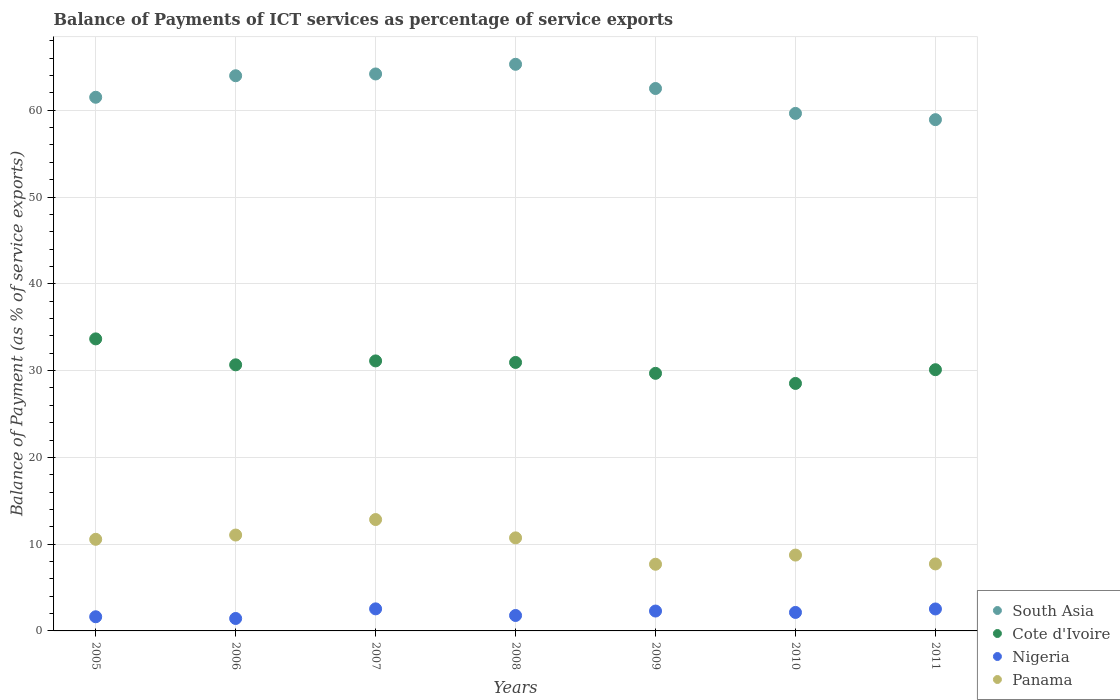How many different coloured dotlines are there?
Your response must be concise. 4. Is the number of dotlines equal to the number of legend labels?
Your response must be concise. Yes. What is the balance of payments of ICT services in Panama in 2009?
Keep it short and to the point. 7.68. Across all years, what is the maximum balance of payments of ICT services in Panama?
Provide a short and direct response. 12.83. Across all years, what is the minimum balance of payments of ICT services in South Asia?
Offer a terse response. 58.92. What is the total balance of payments of ICT services in Cote d'Ivoire in the graph?
Offer a terse response. 214.68. What is the difference between the balance of payments of ICT services in Panama in 2006 and that in 2008?
Ensure brevity in your answer.  0.33. What is the difference between the balance of payments of ICT services in Cote d'Ivoire in 2006 and the balance of payments of ICT services in Nigeria in 2005?
Offer a terse response. 29.03. What is the average balance of payments of ICT services in Nigeria per year?
Make the answer very short. 2.05. In the year 2011, what is the difference between the balance of payments of ICT services in Panama and balance of payments of ICT services in South Asia?
Your answer should be very brief. -51.2. In how many years, is the balance of payments of ICT services in Cote d'Ivoire greater than 30 %?
Offer a terse response. 5. What is the ratio of the balance of payments of ICT services in Cote d'Ivoire in 2006 to that in 2009?
Offer a terse response. 1.03. Is the balance of payments of ICT services in Panama in 2007 less than that in 2009?
Give a very brief answer. No. What is the difference between the highest and the second highest balance of payments of ICT services in Cote d'Ivoire?
Make the answer very short. 2.54. What is the difference between the highest and the lowest balance of payments of ICT services in Cote d'Ivoire?
Your response must be concise. 5.13. In how many years, is the balance of payments of ICT services in Panama greater than the average balance of payments of ICT services in Panama taken over all years?
Your answer should be very brief. 4. Is it the case that in every year, the sum of the balance of payments of ICT services in South Asia and balance of payments of ICT services in Panama  is greater than the sum of balance of payments of ICT services in Cote d'Ivoire and balance of payments of ICT services in Nigeria?
Give a very brief answer. No. Is it the case that in every year, the sum of the balance of payments of ICT services in South Asia and balance of payments of ICT services in Cote d'Ivoire  is greater than the balance of payments of ICT services in Panama?
Your response must be concise. Yes. Does the balance of payments of ICT services in South Asia monotonically increase over the years?
Offer a terse response. No. Is the balance of payments of ICT services in Panama strictly greater than the balance of payments of ICT services in South Asia over the years?
Give a very brief answer. No. How many dotlines are there?
Offer a very short reply. 4. How many years are there in the graph?
Your answer should be compact. 7. What is the difference between two consecutive major ticks on the Y-axis?
Offer a terse response. 10. How many legend labels are there?
Your answer should be very brief. 4. What is the title of the graph?
Offer a terse response. Balance of Payments of ICT services as percentage of service exports. What is the label or title of the Y-axis?
Your answer should be compact. Balance of Payment (as % of service exports). What is the Balance of Payment (as % of service exports) in South Asia in 2005?
Provide a succinct answer. 61.5. What is the Balance of Payment (as % of service exports) of Cote d'Ivoire in 2005?
Keep it short and to the point. 33.65. What is the Balance of Payment (as % of service exports) in Nigeria in 2005?
Offer a terse response. 1.63. What is the Balance of Payment (as % of service exports) of Panama in 2005?
Offer a very short reply. 10.56. What is the Balance of Payment (as % of service exports) in South Asia in 2006?
Offer a very short reply. 63.98. What is the Balance of Payment (as % of service exports) of Cote d'Ivoire in 2006?
Keep it short and to the point. 30.67. What is the Balance of Payment (as % of service exports) in Nigeria in 2006?
Make the answer very short. 1.43. What is the Balance of Payment (as % of service exports) of Panama in 2006?
Offer a terse response. 11.05. What is the Balance of Payment (as % of service exports) in South Asia in 2007?
Offer a terse response. 64.18. What is the Balance of Payment (as % of service exports) of Cote d'Ivoire in 2007?
Your response must be concise. 31.12. What is the Balance of Payment (as % of service exports) of Nigeria in 2007?
Offer a terse response. 2.54. What is the Balance of Payment (as % of service exports) of Panama in 2007?
Make the answer very short. 12.83. What is the Balance of Payment (as % of service exports) of South Asia in 2008?
Give a very brief answer. 65.3. What is the Balance of Payment (as % of service exports) in Cote d'Ivoire in 2008?
Offer a terse response. 30.94. What is the Balance of Payment (as % of service exports) in Nigeria in 2008?
Make the answer very short. 1.78. What is the Balance of Payment (as % of service exports) of Panama in 2008?
Your response must be concise. 10.72. What is the Balance of Payment (as % of service exports) in South Asia in 2009?
Offer a very short reply. 62.51. What is the Balance of Payment (as % of service exports) in Cote d'Ivoire in 2009?
Provide a short and direct response. 29.68. What is the Balance of Payment (as % of service exports) in Nigeria in 2009?
Your answer should be compact. 2.29. What is the Balance of Payment (as % of service exports) of Panama in 2009?
Your answer should be compact. 7.68. What is the Balance of Payment (as % of service exports) of South Asia in 2010?
Your answer should be very brief. 59.64. What is the Balance of Payment (as % of service exports) of Cote d'Ivoire in 2010?
Your answer should be very brief. 28.52. What is the Balance of Payment (as % of service exports) of Nigeria in 2010?
Your answer should be very brief. 2.13. What is the Balance of Payment (as % of service exports) of Panama in 2010?
Offer a very short reply. 8.74. What is the Balance of Payment (as % of service exports) in South Asia in 2011?
Your response must be concise. 58.92. What is the Balance of Payment (as % of service exports) in Cote d'Ivoire in 2011?
Offer a terse response. 30.1. What is the Balance of Payment (as % of service exports) of Nigeria in 2011?
Ensure brevity in your answer.  2.53. What is the Balance of Payment (as % of service exports) of Panama in 2011?
Make the answer very short. 7.72. Across all years, what is the maximum Balance of Payment (as % of service exports) of South Asia?
Offer a very short reply. 65.3. Across all years, what is the maximum Balance of Payment (as % of service exports) of Cote d'Ivoire?
Your response must be concise. 33.65. Across all years, what is the maximum Balance of Payment (as % of service exports) of Nigeria?
Give a very brief answer. 2.54. Across all years, what is the maximum Balance of Payment (as % of service exports) of Panama?
Ensure brevity in your answer.  12.83. Across all years, what is the minimum Balance of Payment (as % of service exports) in South Asia?
Provide a short and direct response. 58.92. Across all years, what is the minimum Balance of Payment (as % of service exports) in Cote d'Ivoire?
Make the answer very short. 28.52. Across all years, what is the minimum Balance of Payment (as % of service exports) in Nigeria?
Offer a very short reply. 1.43. Across all years, what is the minimum Balance of Payment (as % of service exports) of Panama?
Provide a succinct answer. 7.68. What is the total Balance of Payment (as % of service exports) of South Asia in the graph?
Keep it short and to the point. 436.02. What is the total Balance of Payment (as % of service exports) of Cote d'Ivoire in the graph?
Your answer should be very brief. 214.68. What is the total Balance of Payment (as % of service exports) in Nigeria in the graph?
Keep it short and to the point. 14.34. What is the total Balance of Payment (as % of service exports) in Panama in the graph?
Make the answer very short. 69.31. What is the difference between the Balance of Payment (as % of service exports) in South Asia in 2005 and that in 2006?
Offer a terse response. -2.48. What is the difference between the Balance of Payment (as % of service exports) of Cote d'Ivoire in 2005 and that in 2006?
Your answer should be compact. 2.99. What is the difference between the Balance of Payment (as % of service exports) in Nigeria in 2005 and that in 2006?
Your answer should be very brief. 0.2. What is the difference between the Balance of Payment (as % of service exports) of Panama in 2005 and that in 2006?
Your answer should be very brief. -0.49. What is the difference between the Balance of Payment (as % of service exports) of South Asia in 2005 and that in 2007?
Offer a very short reply. -2.69. What is the difference between the Balance of Payment (as % of service exports) of Cote d'Ivoire in 2005 and that in 2007?
Your response must be concise. 2.54. What is the difference between the Balance of Payment (as % of service exports) in Nigeria in 2005 and that in 2007?
Your response must be concise. -0.91. What is the difference between the Balance of Payment (as % of service exports) of Panama in 2005 and that in 2007?
Your answer should be very brief. -2.28. What is the difference between the Balance of Payment (as % of service exports) in South Asia in 2005 and that in 2008?
Provide a succinct answer. -3.8. What is the difference between the Balance of Payment (as % of service exports) of Cote d'Ivoire in 2005 and that in 2008?
Offer a terse response. 2.71. What is the difference between the Balance of Payment (as % of service exports) in Nigeria in 2005 and that in 2008?
Keep it short and to the point. -0.15. What is the difference between the Balance of Payment (as % of service exports) in Panama in 2005 and that in 2008?
Provide a succinct answer. -0.17. What is the difference between the Balance of Payment (as % of service exports) in South Asia in 2005 and that in 2009?
Provide a short and direct response. -1.01. What is the difference between the Balance of Payment (as % of service exports) of Cote d'Ivoire in 2005 and that in 2009?
Your answer should be very brief. 3.97. What is the difference between the Balance of Payment (as % of service exports) in Nigeria in 2005 and that in 2009?
Your answer should be very brief. -0.66. What is the difference between the Balance of Payment (as % of service exports) in Panama in 2005 and that in 2009?
Your response must be concise. 2.87. What is the difference between the Balance of Payment (as % of service exports) of South Asia in 2005 and that in 2010?
Provide a short and direct response. 1.86. What is the difference between the Balance of Payment (as % of service exports) of Cote d'Ivoire in 2005 and that in 2010?
Give a very brief answer. 5.13. What is the difference between the Balance of Payment (as % of service exports) in Nigeria in 2005 and that in 2010?
Keep it short and to the point. -0.5. What is the difference between the Balance of Payment (as % of service exports) of Panama in 2005 and that in 2010?
Provide a short and direct response. 1.82. What is the difference between the Balance of Payment (as % of service exports) in South Asia in 2005 and that in 2011?
Provide a short and direct response. 2.58. What is the difference between the Balance of Payment (as % of service exports) of Cote d'Ivoire in 2005 and that in 2011?
Offer a terse response. 3.55. What is the difference between the Balance of Payment (as % of service exports) of Nigeria in 2005 and that in 2011?
Give a very brief answer. -0.9. What is the difference between the Balance of Payment (as % of service exports) in Panama in 2005 and that in 2011?
Provide a succinct answer. 2.84. What is the difference between the Balance of Payment (as % of service exports) in South Asia in 2006 and that in 2007?
Your answer should be compact. -0.21. What is the difference between the Balance of Payment (as % of service exports) of Cote d'Ivoire in 2006 and that in 2007?
Keep it short and to the point. -0.45. What is the difference between the Balance of Payment (as % of service exports) in Nigeria in 2006 and that in 2007?
Give a very brief answer. -1.11. What is the difference between the Balance of Payment (as % of service exports) in Panama in 2006 and that in 2007?
Keep it short and to the point. -1.78. What is the difference between the Balance of Payment (as % of service exports) of South Asia in 2006 and that in 2008?
Offer a terse response. -1.32. What is the difference between the Balance of Payment (as % of service exports) of Cote d'Ivoire in 2006 and that in 2008?
Give a very brief answer. -0.27. What is the difference between the Balance of Payment (as % of service exports) in Nigeria in 2006 and that in 2008?
Your response must be concise. -0.34. What is the difference between the Balance of Payment (as % of service exports) of Panama in 2006 and that in 2008?
Your answer should be compact. 0.33. What is the difference between the Balance of Payment (as % of service exports) of South Asia in 2006 and that in 2009?
Keep it short and to the point. 1.47. What is the difference between the Balance of Payment (as % of service exports) in Cote d'Ivoire in 2006 and that in 2009?
Your answer should be very brief. 0.98. What is the difference between the Balance of Payment (as % of service exports) of Nigeria in 2006 and that in 2009?
Your response must be concise. -0.86. What is the difference between the Balance of Payment (as % of service exports) in Panama in 2006 and that in 2009?
Make the answer very short. 3.37. What is the difference between the Balance of Payment (as % of service exports) of South Asia in 2006 and that in 2010?
Your answer should be very brief. 4.34. What is the difference between the Balance of Payment (as % of service exports) of Cote d'Ivoire in 2006 and that in 2010?
Your response must be concise. 2.14. What is the difference between the Balance of Payment (as % of service exports) of Nigeria in 2006 and that in 2010?
Your answer should be compact. -0.7. What is the difference between the Balance of Payment (as % of service exports) in Panama in 2006 and that in 2010?
Your answer should be very brief. 2.31. What is the difference between the Balance of Payment (as % of service exports) in South Asia in 2006 and that in 2011?
Keep it short and to the point. 5.06. What is the difference between the Balance of Payment (as % of service exports) in Cote d'Ivoire in 2006 and that in 2011?
Ensure brevity in your answer.  0.56. What is the difference between the Balance of Payment (as % of service exports) of Nigeria in 2006 and that in 2011?
Keep it short and to the point. -1.1. What is the difference between the Balance of Payment (as % of service exports) of Panama in 2006 and that in 2011?
Provide a succinct answer. 3.33. What is the difference between the Balance of Payment (as % of service exports) in South Asia in 2007 and that in 2008?
Your answer should be very brief. -1.11. What is the difference between the Balance of Payment (as % of service exports) in Cote d'Ivoire in 2007 and that in 2008?
Provide a short and direct response. 0.18. What is the difference between the Balance of Payment (as % of service exports) of Nigeria in 2007 and that in 2008?
Provide a succinct answer. 0.76. What is the difference between the Balance of Payment (as % of service exports) of Panama in 2007 and that in 2008?
Provide a short and direct response. 2.11. What is the difference between the Balance of Payment (as % of service exports) of South Asia in 2007 and that in 2009?
Give a very brief answer. 1.68. What is the difference between the Balance of Payment (as % of service exports) in Cote d'Ivoire in 2007 and that in 2009?
Your answer should be compact. 1.43. What is the difference between the Balance of Payment (as % of service exports) of Nigeria in 2007 and that in 2009?
Offer a very short reply. 0.25. What is the difference between the Balance of Payment (as % of service exports) of Panama in 2007 and that in 2009?
Make the answer very short. 5.15. What is the difference between the Balance of Payment (as % of service exports) of South Asia in 2007 and that in 2010?
Offer a terse response. 4.54. What is the difference between the Balance of Payment (as % of service exports) in Cote d'Ivoire in 2007 and that in 2010?
Your answer should be very brief. 2.6. What is the difference between the Balance of Payment (as % of service exports) in Nigeria in 2007 and that in 2010?
Give a very brief answer. 0.41. What is the difference between the Balance of Payment (as % of service exports) in Panama in 2007 and that in 2010?
Offer a terse response. 4.09. What is the difference between the Balance of Payment (as % of service exports) in South Asia in 2007 and that in 2011?
Make the answer very short. 5.27. What is the difference between the Balance of Payment (as % of service exports) in Cote d'Ivoire in 2007 and that in 2011?
Give a very brief answer. 1.01. What is the difference between the Balance of Payment (as % of service exports) in Nigeria in 2007 and that in 2011?
Give a very brief answer. 0.01. What is the difference between the Balance of Payment (as % of service exports) of Panama in 2007 and that in 2011?
Offer a very short reply. 5.11. What is the difference between the Balance of Payment (as % of service exports) in South Asia in 2008 and that in 2009?
Your response must be concise. 2.79. What is the difference between the Balance of Payment (as % of service exports) of Cote d'Ivoire in 2008 and that in 2009?
Give a very brief answer. 1.26. What is the difference between the Balance of Payment (as % of service exports) of Nigeria in 2008 and that in 2009?
Make the answer very short. -0.51. What is the difference between the Balance of Payment (as % of service exports) of Panama in 2008 and that in 2009?
Ensure brevity in your answer.  3.04. What is the difference between the Balance of Payment (as % of service exports) of South Asia in 2008 and that in 2010?
Offer a very short reply. 5.66. What is the difference between the Balance of Payment (as % of service exports) in Cote d'Ivoire in 2008 and that in 2010?
Keep it short and to the point. 2.42. What is the difference between the Balance of Payment (as % of service exports) in Nigeria in 2008 and that in 2010?
Provide a succinct answer. -0.35. What is the difference between the Balance of Payment (as % of service exports) of Panama in 2008 and that in 2010?
Provide a short and direct response. 1.98. What is the difference between the Balance of Payment (as % of service exports) of South Asia in 2008 and that in 2011?
Offer a terse response. 6.38. What is the difference between the Balance of Payment (as % of service exports) in Cote d'Ivoire in 2008 and that in 2011?
Your response must be concise. 0.84. What is the difference between the Balance of Payment (as % of service exports) in Nigeria in 2008 and that in 2011?
Your answer should be very brief. -0.75. What is the difference between the Balance of Payment (as % of service exports) in Panama in 2008 and that in 2011?
Give a very brief answer. 3. What is the difference between the Balance of Payment (as % of service exports) in South Asia in 2009 and that in 2010?
Give a very brief answer. 2.87. What is the difference between the Balance of Payment (as % of service exports) in Cote d'Ivoire in 2009 and that in 2010?
Your answer should be compact. 1.16. What is the difference between the Balance of Payment (as % of service exports) in Nigeria in 2009 and that in 2010?
Make the answer very short. 0.16. What is the difference between the Balance of Payment (as % of service exports) of Panama in 2009 and that in 2010?
Your response must be concise. -1.06. What is the difference between the Balance of Payment (as % of service exports) of South Asia in 2009 and that in 2011?
Provide a succinct answer. 3.59. What is the difference between the Balance of Payment (as % of service exports) of Cote d'Ivoire in 2009 and that in 2011?
Provide a succinct answer. -0.42. What is the difference between the Balance of Payment (as % of service exports) in Nigeria in 2009 and that in 2011?
Your answer should be very brief. -0.24. What is the difference between the Balance of Payment (as % of service exports) in Panama in 2009 and that in 2011?
Provide a short and direct response. -0.04. What is the difference between the Balance of Payment (as % of service exports) in South Asia in 2010 and that in 2011?
Offer a very short reply. 0.72. What is the difference between the Balance of Payment (as % of service exports) in Cote d'Ivoire in 2010 and that in 2011?
Your answer should be compact. -1.58. What is the difference between the Balance of Payment (as % of service exports) of Nigeria in 2010 and that in 2011?
Ensure brevity in your answer.  -0.4. What is the difference between the Balance of Payment (as % of service exports) of Panama in 2010 and that in 2011?
Make the answer very short. 1.02. What is the difference between the Balance of Payment (as % of service exports) in South Asia in 2005 and the Balance of Payment (as % of service exports) in Cote d'Ivoire in 2006?
Offer a terse response. 30.83. What is the difference between the Balance of Payment (as % of service exports) in South Asia in 2005 and the Balance of Payment (as % of service exports) in Nigeria in 2006?
Give a very brief answer. 60.06. What is the difference between the Balance of Payment (as % of service exports) of South Asia in 2005 and the Balance of Payment (as % of service exports) of Panama in 2006?
Offer a terse response. 50.45. What is the difference between the Balance of Payment (as % of service exports) of Cote d'Ivoire in 2005 and the Balance of Payment (as % of service exports) of Nigeria in 2006?
Give a very brief answer. 32.22. What is the difference between the Balance of Payment (as % of service exports) of Cote d'Ivoire in 2005 and the Balance of Payment (as % of service exports) of Panama in 2006?
Keep it short and to the point. 22.6. What is the difference between the Balance of Payment (as % of service exports) in Nigeria in 2005 and the Balance of Payment (as % of service exports) in Panama in 2006?
Make the answer very short. -9.42. What is the difference between the Balance of Payment (as % of service exports) in South Asia in 2005 and the Balance of Payment (as % of service exports) in Cote d'Ivoire in 2007?
Offer a terse response. 30.38. What is the difference between the Balance of Payment (as % of service exports) of South Asia in 2005 and the Balance of Payment (as % of service exports) of Nigeria in 2007?
Offer a very short reply. 58.96. What is the difference between the Balance of Payment (as % of service exports) in South Asia in 2005 and the Balance of Payment (as % of service exports) in Panama in 2007?
Your answer should be compact. 48.66. What is the difference between the Balance of Payment (as % of service exports) in Cote d'Ivoire in 2005 and the Balance of Payment (as % of service exports) in Nigeria in 2007?
Provide a short and direct response. 31.11. What is the difference between the Balance of Payment (as % of service exports) in Cote d'Ivoire in 2005 and the Balance of Payment (as % of service exports) in Panama in 2007?
Ensure brevity in your answer.  20.82. What is the difference between the Balance of Payment (as % of service exports) in Nigeria in 2005 and the Balance of Payment (as % of service exports) in Panama in 2007?
Ensure brevity in your answer.  -11.2. What is the difference between the Balance of Payment (as % of service exports) in South Asia in 2005 and the Balance of Payment (as % of service exports) in Cote d'Ivoire in 2008?
Offer a very short reply. 30.56. What is the difference between the Balance of Payment (as % of service exports) of South Asia in 2005 and the Balance of Payment (as % of service exports) of Nigeria in 2008?
Your answer should be very brief. 59.72. What is the difference between the Balance of Payment (as % of service exports) in South Asia in 2005 and the Balance of Payment (as % of service exports) in Panama in 2008?
Your answer should be very brief. 50.77. What is the difference between the Balance of Payment (as % of service exports) in Cote d'Ivoire in 2005 and the Balance of Payment (as % of service exports) in Nigeria in 2008?
Make the answer very short. 31.88. What is the difference between the Balance of Payment (as % of service exports) of Cote d'Ivoire in 2005 and the Balance of Payment (as % of service exports) of Panama in 2008?
Make the answer very short. 22.93. What is the difference between the Balance of Payment (as % of service exports) in Nigeria in 2005 and the Balance of Payment (as % of service exports) in Panama in 2008?
Ensure brevity in your answer.  -9.09. What is the difference between the Balance of Payment (as % of service exports) in South Asia in 2005 and the Balance of Payment (as % of service exports) in Cote d'Ivoire in 2009?
Provide a succinct answer. 31.81. What is the difference between the Balance of Payment (as % of service exports) of South Asia in 2005 and the Balance of Payment (as % of service exports) of Nigeria in 2009?
Give a very brief answer. 59.21. What is the difference between the Balance of Payment (as % of service exports) in South Asia in 2005 and the Balance of Payment (as % of service exports) in Panama in 2009?
Your response must be concise. 53.81. What is the difference between the Balance of Payment (as % of service exports) in Cote d'Ivoire in 2005 and the Balance of Payment (as % of service exports) in Nigeria in 2009?
Provide a short and direct response. 31.36. What is the difference between the Balance of Payment (as % of service exports) in Cote d'Ivoire in 2005 and the Balance of Payment (as % of service exports) in Panama in 2009?
Your answer should be very brief. 25.97. What is the difference between the Balance of Payment (as % of service exports) of Nigeria in 2005 and the Balance of Payment (as % of service exports) of Panama in 2009?
Offer a terse response. -6.05. What is the difference between the Balance of Payment (as % of service exports) of South Asia in 2005 and the Balance of Payment (as % of service exports) of Cote d'Ivoire in 2010?
Provide a succinct answer. 32.98. What is the difference between the Balance of Payment (as % of service exports) in South Asia in 2005 and the Balance of Payment (as % of service exports) in Nigeria in 2010?
Offer a very short reply. 59.37. What is the difference between the Balance of Payment (as % of service exports) in South Asia in 2005 and the Balance of Payment (as % of service exports) in Panama in 2010?
Provide a succinct answer. 52.76. What is the difference between the Balance of Payment (as % of service exports) in Cote d'Ivoire in 2005 and the Balance of Payment (as % of service exports) in Nigeria in 2010?
Offer a very short reply. 31.52. What is the difference between the Balance of Payment (as % of service exports) in Cote d'Ivoire in 2005 and the Balance of Payment (as % of service exports) in Panama in 2010?
Your answer should be compact. 24.91. What is the difference between the Balance of Payment (as % of service exports) of Nigeria in 2005 and the Balance of Payment (as % of service exports) of Panama in 2010?
Give a very brief answer. -7.11. What is the difference between the Balance of Payment (as % of service exports) of South Asia in 2005 and the Balance of Payment (as % of service exports) of Cote d'Ivoire in 2011?
Provide a short and direct response. 31.4. What is the difference between the Balance of Payment (as % of service exports) of South Asia in 2005 and the Balance of Payment (as % of service exports) of Nigeria in 2011?
Offer a terse response. 58.97. What is the difference between the Balance of Payment (as % of service exports) of South Asia in 2005 and the Balance of Payment (as % of service exports) of Panama in 2011?
Your answer should be very brief. 53.78. What is the difference between the Balance of Payment (as % of service exports) in Cote d'Ivoire in 2005 and the Balance of Payment (as % of service exports) in Nigeria in 2011?
Your response must be concise. 31.12. What is the difference between the Balance of Payment (as % of service exports) in Cote d'Ivoire in 2005 and the Balance of Payment (as % of service exports) in Panama in 2011?
Give a very brief answer. 25.93. What is the difference between the Balance of Payment (as % of service exports) of Nigeria in 2005 and the Balance of Payment (as % of service exports) of Panama in 2011?
Ensure brevity in your answer.  -6.09. What is the difference between the Balance of Payment (as % of service exports) in South Asia in 2006 and the Balance of Payment (as % of service exports) in Cote d'Ivoire in 2007?
Provide a short and direct response. 32.86. What is the difference between the Balance of Payment (as % of service exports) in South Asia in 2006 and the Balance of Payment (as % of service exports) in Nigeria in 2007?
Offer a very short reply. 61.44. What is the difference between the Balance of Payment (as % of service exports) in South Asia in 2006 and the Balance of Payment (as % of service exports) in Panama in 2007?
Give a very brief answer. 51.14. What is the difference between the Balance of Payment (as % of service exports) in Cote d'Ivoire in 2006 and the Balance of Payment (as % of service exports) in Nigeria in 2007?
Provide a short and direct response. 28.12. What is the difference between the Balance of Payment (as % of service exports) in Cote d'Ivoire in 2006 and the Balance of Payment (as % of service exports) in Panama in 2007?
Your answer should be compact. 17.83. What is the difference between the Balance of Payment (as % of service exports) in Nigeria in 2006 and the Balance of Payment (as % of service exports) in Panama in 2007?
Your answer should be compact. -11.4. What is the difference between the Balance of Payment (as % of service exports) in South Asia in 2006 and the Balance of Payment (as % of service exports) in Cote d'Ivoire in 2008?
Offer a very short reply. 33.04. What is the difference between the Balance of Payment (as % of service exports) in South Asia in 2006 and the Balance of Payment (as % of service exports) in Nigeria in 2008?
Offer a terse response. 62.2. What is the difference between the Balance of Payment (as % of service exports) in South Asia in 2006 and the Balance of Payment (as % of service exports) in Panama in 2008?
Your answer should be compact. 53.25. What is the difference between the Balance of Payment (as % of service exports) in Cote d'Ivoire in 2006 and the Balance of Payment (as % of service exports) in Nigeria in 2008?
Keep it short and to the point. 28.89. What is the difference between the Balance of Payment (as % of service exports) in Cote d'Ivoire in 2006 and the Balance of Payment (as % of service exports) in Panama in 2008?
Offer a terse response. 19.94. What is the difference between the Balance of Payment (as % of service exports) of Nigeria in 2006 and the Balance of Payment (as % of service exports) of Panama in 2008?
Offer a terse response. -9.29. What is the difference between the Balance of Payment (as % of service exports) of South Asia in 2006 and the Balance of Payment (as % of service exports) of Cote d'Ivoire in 2009?
Your answer should be very brief. 34.29. What is the difference between the Balance of Payment (as % of service exports) of South Asia in 2006 and the Balance of Payment (as % of service exports) of Nigeria in 2009?
Provide a short and direct response. 61.69. What is the difference between the Balance of Payment (as % of service exports) in South Asia in 2006 and the Balance of Payment (as % of service exports) in Panama in 2009?
Offer a terse response. 56.29. What is the difference between the Balance of Payment (as % of service exports) in Cote d'Ivoire in 2006 and the Balance of Payment (as % of service exports) in Nigeria in 2009?
Keep it short and to the point. 28.37. What is the difference between the Balance of Payment (as % of service exports) of Cote d'Ivoire in 2006 and the Balance of Payment (as % of service exports) of Panama in 2009?
Provide a short and direct response. 22.98. What is the difference between the Balance of Payment (as % of service exports) of Nigeria in 2006 and the Balance of Payment (as % of service exports) of Panama in 2009?
Provide a short and direct response. -6.25. What is the difference between the Balance of Payment (as % of service exports) of South Asia in 2006 and the Balance of Payment (as % of service exports) of Cote d'Ivoire in 2010?
Your answer should be very brief. 35.46. What is the difference between the Balance of Payment (as % of service exports) in South Asia in 2006 and the Balance of Payment (as % of service exports) in Nigeria in 2010?
Offer a terse response. 61.85. What is the difference between the Balance of Payment (as % of service exports) in South Asia in 2006 and the Balance of Payment (as % of service exports) in Panama in 2010?
Your answer should be compact. 55.24. What is the difference between the Balance of Payment (as % of service exports) in Cote d'Ivoire in 2006 and the Balance of Payment (as % of service exports) in Nigeria in 2010?
Your response must be concise. 28.53. What is the difference between the Balance of Payment (as % of service exports) of Cote d'Ivoire in 2006 and the Balance of Payment (as % of service exports) of Panama in 2010?
Make the answer very short. 21.92. What is the difference between the Balance of Payment (as % of service exports) in Nigeria in 2006 and the Balance of Payment (as % of service exports) in Panama in 2010?
Your response must be concise. -7.31. What is the difference between the Balance of Payment (as % of service exports) of South Asia in 2006 and the Balance of Payment (as % of service exports) of Cote d'Ivoire in 2011?
Give a very brief answer. 33.88. What is the difference between the Balance of Payment (as % of service exports) in South Asia in 2006 and the Balance of Payment (as % of service exports) in Nigeria in 2011?
Make the answer very short. 61.45. What is the difference between the Balance of Payment (as % of service exports) of South Asia in 2006 and the Balance of Payment (as % of service exports) of Panama in 2011?
Your response must be concise. 56.26. What is the difference between the Balance of Payment (as % of service exports) of Cote d'Ivoire in 2006 and the Balance of Payment (as % of service exports) of Nigeria in 2011?
Your response must be concise. 28.13. What is the difference between the Balance of Payment (as % of service exports) in Cote d'Ivoire in 2006 and the Balance of Payment (as % of service exports) in Panama in 2011?
Offer a very short reply. 22.94. What is the difference between the Balance of Payment (as % of service exports) of Nigeria in 2006 and the Balance of Payment (as % of service exports) of Panama in 2011?
Make the answer very short. -6.29. What is the difference between the Balance of Payment (as % of service exports) in South Asia in 2007 and the Balance of Payment (as % of service exports) in Cote d'Ivoire in 2008?
Give a very brief answer. 33.24. What is the difference between the Balance of Payment (as % of service exports) of South Asia in 2007 and the Balance of Payment (as % of service exports) of Nigeria in 2008?
Provide a succinct answer. 62.41. What is the difference between the Balance of Payment (as % of service exports) in South Asia in 2007 and the Balance of Payment (as % of service exports) in Panama in 2008?
Ensure brevity in your answer.  53.46. What is the difference between the Balance of Payment (as % of service exports) of Cote d'Ivoire in 2007 and the Balance of Payment (as % of service exports) of Nigeria in 2008?
Offer a very short reply. 29.34. What is the difference between the Balance of Payment (as % of service exports) in Cote d'Ivoire in 2007 and the Balance of Payment (as % of service exports) in Panama in 2008?
Your response must be concise. 20.39. What is the difference between the Balance of Payment (as % of service exports) in Nigeria in 2007 and the Balance of Payment (as % of service exports) in Panama in 2008?
Your response must be concise. -8.18. What is the difference between the Balance of Payment (as % of service exports) of South Asia in 2007 and the Balance of Payment (as % of service exports) of Cote d'Ivoire in 2009?
Keep it short and to the point. 34.5. What is the difference between the Balance of Payment (as % of service exports) in South Asia in 2007 and the Balance of Payment (as % of service exports) in Nigeria in 2009?
Your answer should be very brief. 61.89. What is the difference between the Balance of Payment (as % of service exports) of South Asia in 2007 and the Balance of Payment (as % of service exports) of Panama in 2009?
Provide a short and direct response. 56.5. What is the difference between the Balance of Payment (as % of service exports) of Cote d'Ivoire in 2007 and the Balance of Payment (as % of service exports) of Nigeria in 2009?
Offer a very short reply. 28.82. What is the difference between the Balance of Payment (as % of service exports) of Cote d'Ivoire in 2007 and the Balance of Payment (as % of service exports) of Panama in 2009?
Offer a terse response. 23.43. What is the difference between the Balance of Payment (as % of service exports) in Nigeria in 2007 and the Balance of Payment (as % of service exports) in Panama in 2009?
Keep it short and to the point. -5.14. What is the difference between the Balance of Payment (as % of service exports) of South Asia in 2007 and the Balance of Payment (as % of service exports) of Cote d'Ivoire in 2010?
Provide a short and direct response. 35.66. What is the difference between the Balance of Payment (as % of service exports) in South Asia in 2007 and the Balance of Payment (as % of service exports) in Nigeria in 2010?
Offer a terse response. 62.05. What is the difference between the Balance of Payment (as % of service exports) of South Asia in 2007 and the Balance of Payment (as % of service exports) of Panama in 2010?
Your response must be concise. 55.44. What is the difference between the Balance of Payment (as % of service exports) in Cote d'Ivoire in 2007 and the Balance of Payment (as % of service exports) in Nigeria in 2010?
Your answer should be very brief. 28.98. What is the difference between the Balance of Payment (as % of service exports) in Cote d'Ivoire in 2007 and the Balance of Payment (as % of service exports) in Panama in 2010?
Ensure brevity in your answer.  22.37. What is the difference between the Balance of Payment (as % of service exports) in Nigeria in 2007 and the Balance of Payment (as % of service exports) in Panama in 2010?
Offer a terse response. -6.2. What is the difference between the Balance of Payment (as % of service exports) in South Asia in 2007 and the Balance of Payment (as % of service exports) in Cote d'Ivoire in 2011?
Provide a short and direct response. 34.08. What is the difference between the Balance of Payment (as % of service exports) of South Asia in 2007 and the Balance of Payment (as % of service exports) of Nigeria in 2011?
Offer a terse response. 61.65. What is the difference between the Balance of Payment (as % of service exports) of South Asia in 2007 and the Balance of Payment (as % of service exports) of Panama in 2011?
Offer a very short reply. 56.46. What is the difference between the Balance of Payment (as % of service exports) of Cote d'Ivoire in 2007 and the Balance of Payment (as % of service exports) of Nigeria in 2011?
Your answer should be compact. 28.59. What is the difference between the Balance of Payment (as % of service exports) of Cote d'Ivoire in 2007 and the Balance of Payment (as % of service exports) of Panama in 2011?
Your answer should be very brief. 23.39. What is the difference between the Balance of Payment (as % of service exports) in Nigeria in 2007 and the Balance of Payment (as % of service exports) in Panama in 2011?
Keep it short and to the point. -5.18. What is the difference between the Balance of Payment (as % of service exports) of South Asia in 2008 and the Balance of Payment (as % of service exports) of Cote d'Ivoire in 2009?
Give a very brief answer. 35.61. What is the difference between the Balance of Payment (as % of service exports) in South Asia in 2008 and the Balance of Payment (as % of service exports) in Nigeria in 2009?
Offer a very short reply. 63.01. What is the difference between the Balance of Payment (as % of service exports) of South Asia in 2008 and the Balance of Payment (as % of service exports) of Panama in 2009?
Ensure brevity in your answer.  57.62. What is the difference between the Balance of Payment (as % of service exports) in Cote d'Ivoire in 2008 and the Balance of Payment (as % of service exports) in Nigeria in 2009?
Your answer should be very brief. 28.65. What is the difference between the Balance of Payment (as % of service exports) in Cote d'Ivoire in 2008 and the Balance of Payment (as % of service exports) in Panama in 2009?
Make the answer very short. 23.26. What is the difference between the Balance of Payment (as % of service exports) in Nigeria in 2008 and the Balance of Payment (as % of service exports) in Panama in 2009?
Your answer should be very brief. -5.91. What is the difference between the Balance of Payment (as % of service exports) in South Asia in 2008 and the Balance of Payment (as % of service exports) in Cote d'Ivoire in 2010?
Give a very brief answer. 36.78. What is the difference between the Balance of Payment (as % of service exports) of South Asia in 2008 and the Balance of Payment (as % of service exports) of Nigeria in 2010?
Your response must be concise. 63.17. What is the difference between the Balance of Payment (as % of service exports) in South Asia in 2008 and the Balance of Payment (as % of service exports) in Panama in 2010?
Offer a terse response. 56.56. What is the difference between the Balance of Payment (as % of service exports) in Cote d'Ivoire in 2008 and the Balance of Payment (as % of service exports) in Nigeria in 2010?
Your response must be concise. 28.81. What is the difference between the Balance of Payment (as % of service exports) in Cote d'Ivoire in 2008 and the Balance of Payment (as % of service exports) in Panama in 2010?
Offer a very short reply. 22.2. What is the difference between the Balance of Payment (as % of service exports) of Nigeria in 2008 and the Balance of Payment (as % of service exports) of Panama in 2010?
Make the answer very short. -6.96. What is the difference between the Balance of Payment (as % of service exports) of South Asia in 2008 and the Balance of Payment (as % of service exports) of Cote d'Ivoire in 2011?
Offer a very short reply. 35.2. What is the difference between the Balance of Payment (as % of service exports) of South Asia in 2008 and the Balance of Payment (as % of service exports) of Nigeria in 2011?
Make the answer very short. 62.77. What is the difference between the Balance of Payment (as % of service exports) of South Asia in 2008 and the Balance of Payment (as % of service exports) of Panama in 2011?
Offer a very short reply. 57.58. What is the difference between the Balance of Payment (as % of service exports) in Cote d'Ivoire in 2008 and the Balance of Payment (as % of service exports) in Nigeria in 2011?
Give a very brief answer. 28.41. What is the difference between the Balance of Payment (as % of service exports) of Cote d'Ivoire in 2008 and the Balance of Payment (as % of service exports) of Panama in 2011?
Your response must be concise. 23.22. What is the difference between the Balance of Payment (as % of service exports) of Nigeria in 2008 and the Balance of Payment (as % of service exports) of Panama in 2011?
Provide a succinct answer. -5.94. What is the difference between the Balance of Payment (as % of service exports) in South Asia in 2009 and the Balance of Payment (as % of service exports) in Cote d'Ivoire in 2010?
Provide a short and direct response. 33.99. What is the difference between the Balance of Payment (as % of service exports) in South Asia in 2009 and the Balance of Payment (as % of service exports) in Nigeria in 2010?
Your answer should be compact. 60.38. What is the difference between the Balance of Payment (as % of service exports) in South Asia in 2009 and the Balance of Payment (as % of service exports) in Panama in 2010?
Ensure brevity in your answer.  53.77. What is the difference between the Balance of Payment (as % of service exports) of Cote d'Ivoire in 2009 and the Balance of Payment (as % of service exports) of Nigeria in 2010?
Your answer should be very brief. 27.55. What is the difference between the Balance of Payment (as % of service exports) of Cote d'Ivoire in 2009 and the Balance of Payment (as % of service exports) of Panama in 2010?
Make the answer very short. 20.94. What is the difference between the Balance of Payment (as % of service exports) in Nigeria in 2009 and the Balance of Payment (as % of service exports) in Panama in 2010?
Give a very brief answer. -6.45. What is the difference between the Balance of Payment (as % of service exports) of South Asia in 2009 and the Balance of Payment (as % of service exports) of Cote d'Ivoire in 2011?
Your response must be concise. 32.41. What is the difference between the Balance of Payment (as % of service exports) in South Asia in 2009 and the Balance of Payment (as % of service exports) in Nigeria in 2011?
Give a very brief answer. 59.98. What is the difference between the Balance of Payment (as % of service exports) in South Asia in 2009 and the Balance of Payment (as % of service exports) in Panama in 2011?
Make the answer very short. 54.79. What is the difference between the Balance of Payment (as % of service exports) in Cote d'Ivoire in 2009 and the Balance of Payment (as % of service exports) in Nigeria in 2011?
Your answer should be compact. 27.15. What is the difference between the Balance of Payment (as % of service exports) in Cote d'Ivoire in 2009 and the Balance of Payment (as % of service exports) in Panama in 2011?
Your answer should be compact. 21.96. What is the difference between the Balance of Payment (as % of service exports) of Nigeria in 2009 and the Balance of Payment (as % of service exports) of Panama in 2011?
Your response must be concise. -5.43. What is the difference between the Balance of Payment (as % of service exports) in South Asia in 2010 and the Balance of Payment (as % of service exports) in Cote d'Ivoire in 2011?
Provide a succinct answer. 29.54. What is the difference between the Balance of Payment (as % of service exports) of South Asia in 2010 and the Balance of Payment (as % of service exports) of Nigeria in 2011?
Offer a terse response. 57.11. What is the difference between the Balance of Payment (as % of service exports) in South Asia in 2010 and the Balance of Payment (as % of service exports) in Panama in 2011?
Provide a short and direct response. 51.92. What is the difference between the Balance of Payment (as % of service exports) in Cote d'Ivoire in 2010 and the Balance of Payment (as % of service exports) in Nigeria in 2011?
Ensure brevity in your answer.  25.99. What is the difference between the Balance of Payment (as % of service exports) in Cote d'Ivoire in 2010 and the Balance of Payment (as % of service exports) in Panama in 2011?
Your answer should be very brief. 20.8. What is the difference between the Balance of Payment (as % of service exports) of Nigeria in 2010 and the Balance of Payment (as % of service exports) of Panama in 2011?
Your answer should be compact. -5.59. What is the average Balance of Payment (as % of service exports) in South Asia per year?
Keep it short and to the point. 62.29. What is the average Balance of Payment (as % of service exports) of Cote d'Ivoire per year?
Provide a short and direct response. 30.67. What is the average Balance of Payment (as % of service exports) in Nigeria per year?
Your answer should be very brief. 2.05. What is the average Balance of Payment (as % of service exports) in Panama per year?
Provide a short and direct response. 9.9. In the year 2005, what is the difference between the Balance of Payment (as % of service exports) of South Asia and Balance of Payment (as % of service exports) of Cote d'Ivoire?
Make the answer very short. 27.84. In the year 2005, what is the difference between the Balance of Payment (as % of service exports) of South Asia and Balance of Payment (as % of service exports) of Nigeria?
Your response must be concise. 59.87. In the year 2005, what is the difference between the Balance of Payment (as % of service exports) in South Asia and Balance of Payment (as % of service exports) in Panama?
Your answer should be very brief. 50.94. In the year 2005, what is the difference between the Balance of Payment (as % of service exports) in Cote d'Ivoire and Balance of Payment (as % of service exports) in Nigeria?
Offer a very short reply. 32.02. In the year 2005, what is the difference between the Balance of Payment (as % of service exports) of Cote d'Ivoire and Balance of Payment (as % of service exports) of Panama?
Your response must be concise. 23.1. In the year 2005, what is the difference between the Balance of Payment (as % of service exports) of Nigeria and Balance of Payment (as % of service exports) of Panama?
Provide a succinct answer. -8.93. In the year 2006, what is the difference between the Balance of Payment (as % of service exports) in South Asia and Balance of Payment (as % of service exports) in Cote d'Ivoire?
Ensure brevity in your answer.  33.31. In the year 2006, what is the difference between the Balance of Payment (as % of service exports) in South Asia and Balance of Payment (as % of service exports) in Nigeria?
Give a very brief answer. 62.54. In the year 2006, what is the difference between the Balance of Payment (as % of service exports) in South Asia and Balance of Payment (as % of service exports) in Panama?
Your answer should be very brief. 52.93. In the year 2006, what is the difference between the Balance of Payment (as % of service exports) in Cote d'Ivoire and Balance of Payment (as % of service exports) in Nigeria?
Ensure brevity in your answer.  29.23. In the year 2006, what is the difference between the Balance of Payment (as % of service exports) in Cote d'Ivoire and Balance of Payment (as % of service exports) in Panama?
Your answer should be very brief. 19.62. In the year 2006, what is the difference between the Balance of Payment (as % of service exports) of Nigeria and Balance of Payment (as % of service exports) of Panama?
Make the answer very short. -9.62. In the year 2007, what is the difference between the Balance of Payment (as % of service exports) in South Asia and Balance of Payment (as % of service exports) in Cote d'Ivoire?
Make the answer very short. 33.07. In the year 2007, what is the difference between the Balance of Payment (as % of service exports) in South Asia and Balance of Payment (as % of service exports) in Nigeria?
Provide a succinct answer. 61.64. In the year 2007, what is the difference between the Balance of Payment (as % of service exports) in South Asia and Balance of Payment (as % of service exports) in Panama?
Offer a very short reply. 51.35. In the year 2007, what is the difference between the Balance of Payment (as % of service exports) in Cote d'Ivoire and Balance of Payment (as % of service exports) in Nigeria?
Your response must be concise. 28.57. In the year 2007, what is the difference between the Balance of Payment (as % of service exports) of Cote d'Ivoire and Balance of Payment (as % of service exports) of Panama?
Give a very brief answer. 18.28. In the year 2007, what is the difference between the Balance of Payment (as % of service exports) in Nigeria and Balance of Payment (as % of service exports) in Panama?
Your answer should be very brief. -10.29. In the year 2008, what is the difference between the Balance of Payment (as % of service exports) in South Asia and Balance of Payment (as % of service exports) in Cote d'Ivoire?
Keep it short and to the point. 34.36. In the year 2008, what is the difference between the Balance of Payment (as % of service exports) in South Asia and Balance of Payment (as % of service exports) in Nigeria?
Make the answer very short. 63.52. In the year 2008, what is the difference between the Balance of Payment (as % of service exports) of South Asia and Balance of Payment (as % of service exports) of Panama?
Your answer should be compact. 54.58. In the year 2008, what is the difference between the Balance of Payment (as % of service exports) in Cote d'Ivoire and Balance of Payment (as % of service exports) in Nigeria?
Keep it short and to the point. 29.16. In the year 2008, what is the difference between the Balance of Payment (as % of service exports) in Cote d'Ivoire and Balance of Payment (as % of service exports) in Panama?
Keep it short and to the point. 20.22. In the year 2008, what is the difference between the Balance of Payment (as % of service exports) in Nigeria and Balance of Payment (as % of service exports) in Panama?
Offer a very short reply. -8.95. In the year 2009, what is the difference between the Balance of Payment (as % of service exports) in South Asia and Balance of Payment (as % of service exports) in Cote d'Ivoire?
Offer a very short reply. 32.82. In the year 2009, what is the difference between the Balance of Payment (as % of service exports) in South Asia and Balance of Payment (as % of service exports) in Nigeria?
Ensure brevity in your answer.  60.22. In the year 2009, what is the difference between the Balance of Payment (as % of service exports) of South Asia and Balance of Payment (as % of service exports) of Panama?
Provide a succinct answer. 54.82. In the year 2009, what is the difference between the Balance of Payment (as % of service exports) in Cote d'Ivoire and Balance of Payment (as % of service exports) in Nigeria?
Ensure brevity in your answer.  27.39. In the year 2009, what is the difference between the Balance of Payment (as % of service exports) in Cote d'Ivoire and Balance of Payment (as % of service exports) in Panama?
Ensure brevity in your answer.  22. In the year 2009, what is the difference between the Balance of Payment (as % of service exports) of Nigeria and Balance of Payment (as % of service exports) of Panama?
Ensure brevity in your answer.  -5.39. In the year 2010, what is the difference between the Balance of Payment (as % of service exports) in South Asia and Balance of Payment (as % of service exports) in Cote d'Ivoire?
Ensure brevity in your answer.  31.12. In the year 2010, what is the difference between the Balance of Payment (as % of service exports) of South Asia and Balance of Payment (as % of service exports) of Nigeria?
Offer a terse response. 57.51. In the year 2010, what is the difference between the Balance of Payment (as % of service exports) of South Asia and Balance of Payment (as % of service exports) of Panama?
Offer a very short reply. 50.9. In the year 2010, what is the difference between the Balance of Payment (as % of service exports) of Cote d'Ivoire and Balance of Payment (as % of service exports) of Nigeria?
Keep it short and to the point. 26.39. In the year 2010, what is the difference between the Balance of Payment (as % of service exports) of Cote d'Ivoire and Balance of Payment (as % of service exports) of Panama?
Give a very brief answer. 19.78. In the year 2010, what is the difference between the Balance of Payment (as % of service exports) of Nigeria and Balance of Payment (as % of service exports) of Panama?
Your answer should be very brief. -6.61. In the year 2011, what is the difference between the Balance of Payment (as % of service exports) in South Asia and Balance of Payment (as % of service exports) in Cote d'Ivoire?
Your response must be concise. 28.82. In the year 2011, what is the difference between the Balance of Payment (as % of service exports) in South Asia and Balance of Payment (as % of service exports) in Nigeria?
Keep it short and to the point. 56.39. In the year 2011, what is the difference between the Balance of Payment (as % of service exports) in South Asia and Balance of Payment (as % of service exports) in Panama?
Offer a very short reply. 51.2. In the year 2011, what is the difference between the Balance of Payment (as % of service exports) in Cote d'Ivoire and Balance of Payment (as % of service exports) in Nigeria?
Your answer should be very brief. 27.57. In the year 2011, what is the difference between the Balance of Payment (as % of service exports) of Cote d'Ivoire and Balance of Payment (as % of service exports) of Panama?
Give a very brief answer. 22.38. In the year 2011, what is the difference between the Balance of Payment (as % of service exports) of Nigeria and Balance of Payment (as % of service exports) of Panama?
Your answer should be very brief. -5.19. What is the ratio of the Balance of Payment (as % of service exports) of South Asia in 2005 to that in 2006?
Provide a short and direct response. 0.96. What is the ratio of the Balance of Payment (as % of service exports) of Cote d'Ivoire in 2005 to that in 2006?
Your response must be concise. 1.1. What is the ratio of the Balance of Payment (as % of service exports) of Nigeria in 2005 to that in 2006?
Provide a short and direct response. 1.14. What is the ratio of the Balance of Payment (as % of service exports) in Panama in 2005 to that in 2006?
Keep it short and to the point. 0.96. What is the ratio of the Balance of Payment (as % of service exports) of South Asia in 2005 to that in 2007?
Offer a very short reply. 0.96. What is the ratio of the Balance of Payment (as % of service exports) of Cote d'Ivoire in 2005 to that in 2007?
Your response must be concise. 1.08. What is the ratio of the Balance of Payment (as % of service exports) in Nigeria in 2005 to that in 2007?
Offer a terse response. 0.64. What is the ratio of the Balance of Payment (as % of service exports) in Panama in 2005 to that in 2007?
Keep it short and to the point. 0.82. What is the ratio of the Balance of Payment (as % of service exports) of South Asia in 2005 to that in 2008?
Provide a succinct answer. 0.94. What is the ratio of the Balance of Payment (as % of service exports) of Cote d'Ivoire in 2005 to that in 2008?
Offer a terse response. 1.09. What is the ratio of the Balance of Payment (as % of service exports) of Nigeria in 2005 to that in 2008?
Offer a terse response. 0.92. What is the ratio of the Balance of Payment (as % of service exports) in Panama in 2005 to that in 2008?
Provide a succinct answer. 0.98. What is the ratio of the Balance of Payment (as % of service exports) in South Asia in 2005 to that in 2009?
Provide a short and direct response. 0.98. What is the ratio of the Balance of Payment (as % of service exports) of Cote d'Ivoire in 2005 to that in 2009?
Offer a terse response. 1.13. What is the ratio of the Balance of Payment (as % of service exports) in Nigeria in 2005 to that in 2009?
Your answer should be compact. 0.71. What is the ratio of the Balance of Payment (as % of service exports) in Panama in 2005 to that in 2009?
Make the answer very short. 1.37. What is the ratio of the Balance of Payment (as % of service exports) in South Asia in 2005 to that in 2010?
Provide a succinct answer. 1.03. What is the ratio of the Balance of Payment (as % of service exports) in Cote d'Ivoire in 2005 to that in 2010?
Keep it short and to the point. 1.18. What is the ratio of the Balance of Payment (as % of service exports) in Nigeria in 2005 to that in 2010?
Keep it short and to the point. 0.77. What is the ratio of the Balance of Payment (as % of service exports) in Panama in 2005 to that in 2010?
Offer a very short reply. 1.21. What is the ratio of the Balance of Payment (as % of service exports) of South Asia in 2005 to that in 2011?
Make the answer very short. 1.04. What is the ratio of the Balance of Payment (as % of service exports) in Cote d'Ivoire in 2005 to that in 2011?
Keep it short and to the point. 1.12. What is the ratio of the Balance of Payment (as % of service exports) of Nigeria in 2005 to that in 2011?
Offer a very short reply. 0.64. What is the ratio of the Balance of Payment (as % of service exports) of Panama in 2005 to that in 2011?
Give a very brief answer. 1.37. What is the ratio of the Balance of Payment (as % of service exports) of Cote d'Ivoire in 2006 to that in 2007?
Make the answer very short. 0.99. What is the ratio of the Balance of Payment (as % of service exports) in Nigeria in 2006 to that in 2007?
Offer a terse response. 0.56. What is the ratio of the Balance of Payment (as % of service exports) in Panama in 2006 to that in 2007?
Your answer should be very brief. 0.86. What is the ratio of the Balance of Payment (as % of service exports) of South Asia in 2006 to that in 2008?
Offer a very short reply. 0.98. What is the ratio of the Balance of Payment (as % of service exports) in Cote d'Ivoire in 2006 to that in 2008?
Your answer should be very brief. 0.99. What is the ratio of the Balance of Payment (as % of service exports) in Nigeria in 2006 to that in 2008?
Your answer should be compact. 0.81. What is the ratio of the Balance of Payment (as % of service exports) of Panama in 2006 to that in 2008?
Give a very brief answer. 1.03. What is the ratio of the Balance of Payment (as % of service exports) in South Asia in 2006 to that in 2009?
Your response must be concise. 1.02. What is the ratio of the Balance of Payment (as % of service exports) in Cote d'Ivoire in 2006 to that in 2009?
Offer a terse response. 1.03. What is the ratio of the Balance of Payment (as % of service exports) of Nigeria in 2006 to that in 2009?
Provide a succinct answer. 0.63. What is the ratio of the Balance of Payment (as % of service exports) in Panama in 2006 to that in 2009?
Provide a short and direct response. 1.44. What is the ratio of the Balance of Payment (as % of service exports) of South Asia in 2006 to that in 2010?
Your response must be concise. 1.07. What is the ratio of the Balance of Payment (as % of service exports) in Cote d'Ivoire in 2006 to that in 2010?
Give a very brief answer. 1.08. What is the ratio of the Balance of Payment (as % of service exports) in Nigeria in 2006 to that in 2010?
Keep it short and to the point. 0.67. What is the ratio of the Balance of Payment (as % of service exports) in Panama in 2006 to that in 2010?
Your answer should be very brief. 1.26. What is the ratio of the Balance of Payment (as % of service exports) of South Asia in 2006 to that in 2011?
Your answer should be compact. 1.09. What is the ratio of the Balance of Payment (as % of service exports) of Cote d'Ivoire in 2006 to that in 2011?
Your answer should be compact. 1.02. What is the ratio of the Balance of Payment (as % of service exports) in Nigeria in 2006 to that in 2011?
Your answer should be very brief. 0.57. What is the ratio of the Balance of Payment (as % of service exports) of Panama in 2006 to that in 2011?
Give a very brief answer. 1.43. What is the ratio of the Balance of Payment (as % of service exports) in South Asia in 2007 to that in 2008?
Ensure brevity in your answer.  0.98. What is the ratio of the Balance of Payment (as % of service exports) in Nigeria in 2007 to that in 2008?
Offer a very short reply. 1.43. What is the ratio of the Balance of Payment (as % of service exports) in Panama in 2007 to that in 2008?
Provide a short and direct response. 1.2. What is the ratio of the Balance of Payment (as % of service exports) of South Asia in 2007 to that in 2009?
Keep it short and to the point. 1.03. What is the ratio of the Balance of Payment (as % of service exports) in Cote d'Ivoire in 2007 to that in 2009?
Ensure brevity in your answer.  1.05. What is the ratio of the Balance of Payment (as % of service exports) in Nigeria in 2007 to that in 2009?
Provide a succinct answer. 1.11. What is the ratio of the Balance of Payment (as % of service exports) of Panama in 2007 to that in 2009?
Ensure brevity in your answer.  1.67. What is the ratio of the Balance of Payment (as % of service exports) of South Asia in 2007 to that in 2010?
Make the answer very short. 1.08. What is the ratio of the Balance of Payment (as % of service exports) in Cote d'Ivoire in 2007 to that in 2010?
Make the answer very short. 1.09. What is the ratio of the Balance of Payment (as % of service exports) in Nigeria in 2007 to that in 2010?
Your response must be concise. 1.19. What is the ratio of the Balance of Payment (as % of service exports) in Panama in 2007 to that in 2010?
Ensure brevity in your answer.  1.47. What is the ratio of the Balance of Payment (as % of service exports) of South Asia in 2007 to that in 2011?
Make the answer very short. 1.09. What is the ratio of the Balance of Payment (as % of service exports) in Cote d'Ivoire in 2007 to that in 2011?
Give a very brief answer. 1.03. What is the ratio of the Balance of Payment (as % of service exports) of Nigeria in 2007 to that in 2011?
Offer a terse response. 1. What is the ratio of the Balance of Payment (as % of service exports) of Panama in 2007 to that in 2011?
Ensure brevity in your answer.  1.66. What is the ratio of the Balance of Payment (as % of service exports) of South Asia in 2008 to that in 2009?
Ensure brevity in your answer.  1.04. What is the ratio of the Balance of Payment (as % of service exports) in Cote d'Ivoire in 2008 to that in 2009?
Give a very brief answer. 1.04. What is the ratio of the Balance of Payment (as % of service exports) in Nigeria in 2008 to that in 2009?
Keep it short and to the point. 0.78. What is the ratio of the Balance of Payment (as % of service exports) in Panama in 2008 to that in 2009?
Give a very brief answer. 1.4. What is the ratio of the Balance of Payment (as % of service exports) in South Asia in 2008 to that in 2010?
Offer a terse response. 1.09. What is the ratio of the Balance of Payment (as % of service exports) in Cote d'Ivoire in 2008 to that in 2010?
Offer a very short reply. 1.08. What is the ratio of the Balance of Payment (as % of service exports) of Nigeria in 2008 to that in 2010?
Offer a very short reply. 0.83. What is the ratio of the Balance of Payment (as % of service exports) in Panama in 2008 to that in 2010?
Make the answer very short. 1.23. What is the ratio of the Balance of Payment (as % of service exports) of South Asia in 2008 to that in 2011?
Provide a short and direct response. 1.11. What is the ratio of the Balance of Payment (as % of service exports) of Cote d'Ivoire in 2008 to that in 2011?
Give a very brief answer. 1.03. What is the ratio of the Balance of Payment (as % of service exports) of Nigeria in 2008 to that in 2011?
Give a very brief answer. 0.7. What is the ratio of the Balance of Payment (as % of service exports) of Panama in 2008 to that in 2011?
Keep it short and to the point. 1.39. What is the ratio of the Balance of Payment (as % of service exports) in South Asia in 2009 to that in 2010?
Offer a very short reply. 1.05. What is the ratio of the Balance of Payment (as % of service exports) in Cote d'Ivoire in 2009 to that in 2010?
Your answer should be compact. 1.04. What is the ratio of the Balance of Payment (as % of service exports) in Nigeria in 2009 to that in 2010?
Keep it short and to the point. 1.07. What is the ratio of the Balance of Payment (as % of service exports) in Panama in 2009 to that in 2010?
Ensure brevity in your answer.  0.88. What is the ratio of the Balance of Payment (as % of service exports) in South Asia in 2009 to that in 2011?
Your answer should be very brief. 1.06. What is the ratio of the Balance of Payment (as % of service exports) of Cote d'Ivoire in 2009 to that in 2011?
Make the answer very short. 0.99. What is the ratio of the Balance of Payment (as % of service exports) of Nigeria in 2009 to that in 2011?
Make the answer very short. 0.91. What is the ratio of the Balance of Payment (as % of service exports) of South Asia in 2010 to that in 2011?
Give a very brief answer. 1.01. What is the ratio of the Balance of Payment (as % of service exports) in Cote d'Ivoire in 2010 to that in 2011?
Provide a succinct answer. 0.95. What is the ratio of the Balance of Payment (as % of service exports) of Nigeria in 2010 to that in 2011?
Ensure brevity in your answer.  0.84. What is the ratio of the Balance of Payment (as % of service exports) in Panama in 2010 to that in 2011?
Your response must be concise. 1.13. What is the difference between the highest and the second highest Balance of Payment (as % of service exports) of South Asia?
Ensure brevity in your answer.  1.11. What is the difference between the highest and the second highest Balance of Payment (as % of service exports) of Cote d'Ivoire?
Your response must be concise. 2.54. What is the difference between the highest and the second highest Balance of Payment (as % of service exports) of Nigeria?
Ensure brevity in your answer.  0.01. What is the difference between the highest and the second highest Balance of Payment (as % of service exports) in Panama?
Your answer should be very brief. 1.78. What is the difference between the highest and the lowest Balance of Payment (as % of service exports) in South Asia?
Provide a short and direct response. 6.38. What is the difference between the highest and the lowest Balance of Payment (as % of service exports) in Cote d'Ivoire?
Your answer should be very brief. 5.13. What is the difference between the highest and the lowest Balance of Payment (as % of service exports) in Nigeria?
Keep it short and to the point. 1.11. What is the difference between the highest and the lowest Balance of Payment (as % of service exports) of Panama?
Provide a short and direct response. 5.15. 